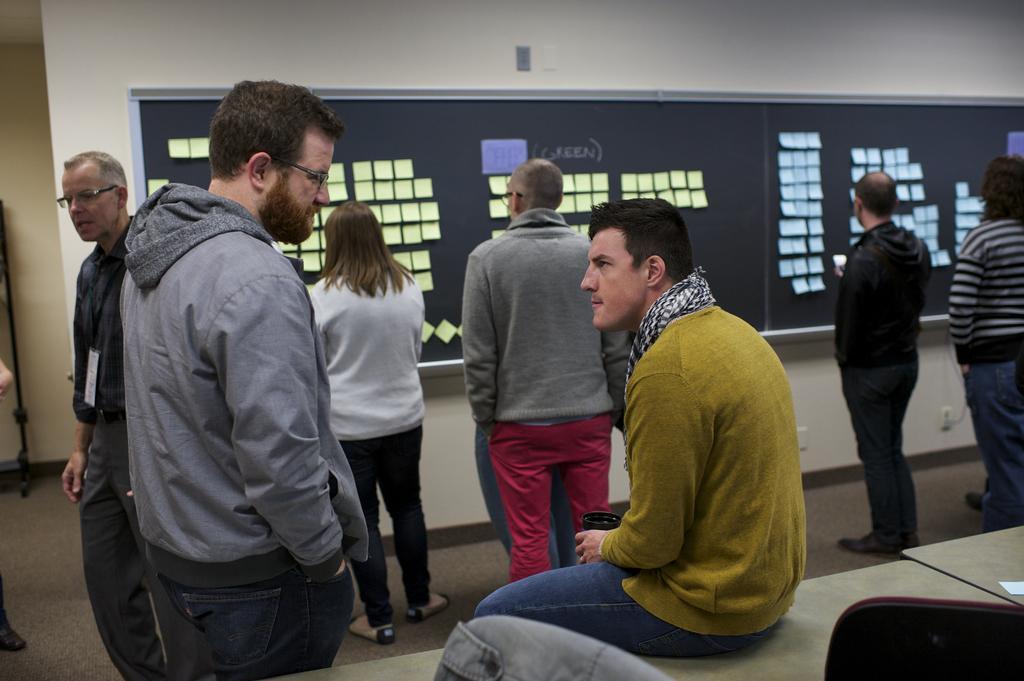Describe this image in one or two sentences. This is the picture of a room. In the foreground there is a person with green sweatshirt is sitting and holding the cup. There are group of people standing. In the bottom right there is a chair and there is a paper on the table. At the back there are papers on the board. There is a board on the wall. On the left side of the image there is a stand. At the bottom there is a switch board on the wall. 